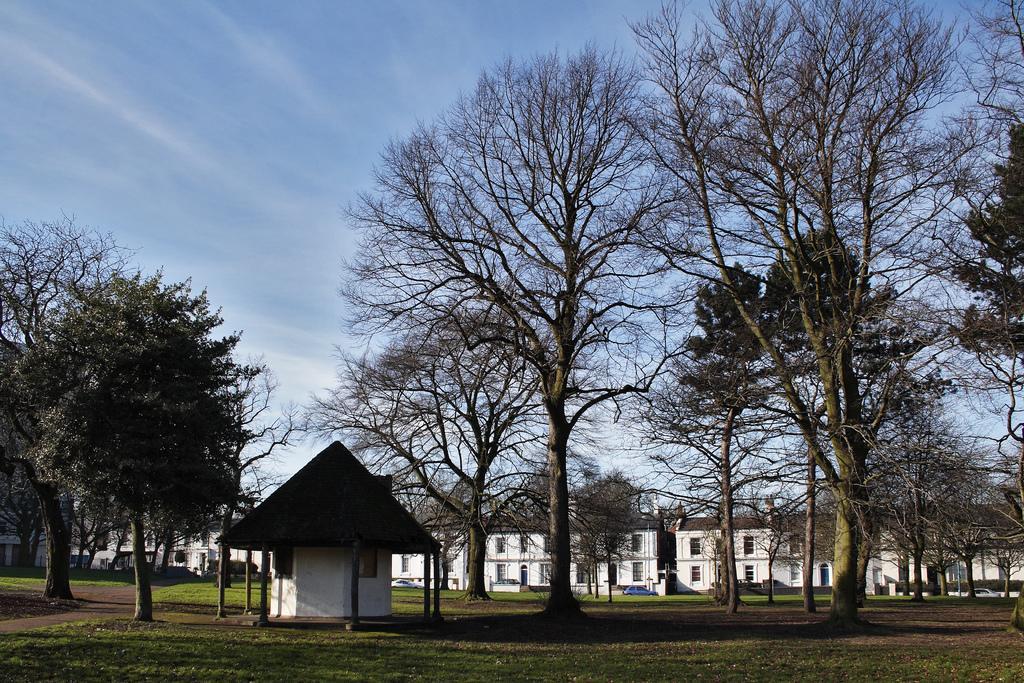Can you describe this image briefly? In this image we can see trees. Also there is a shed with pillars. Also there are buildings with windows. On the ground there is grass. In the background there is sky with clouds. 